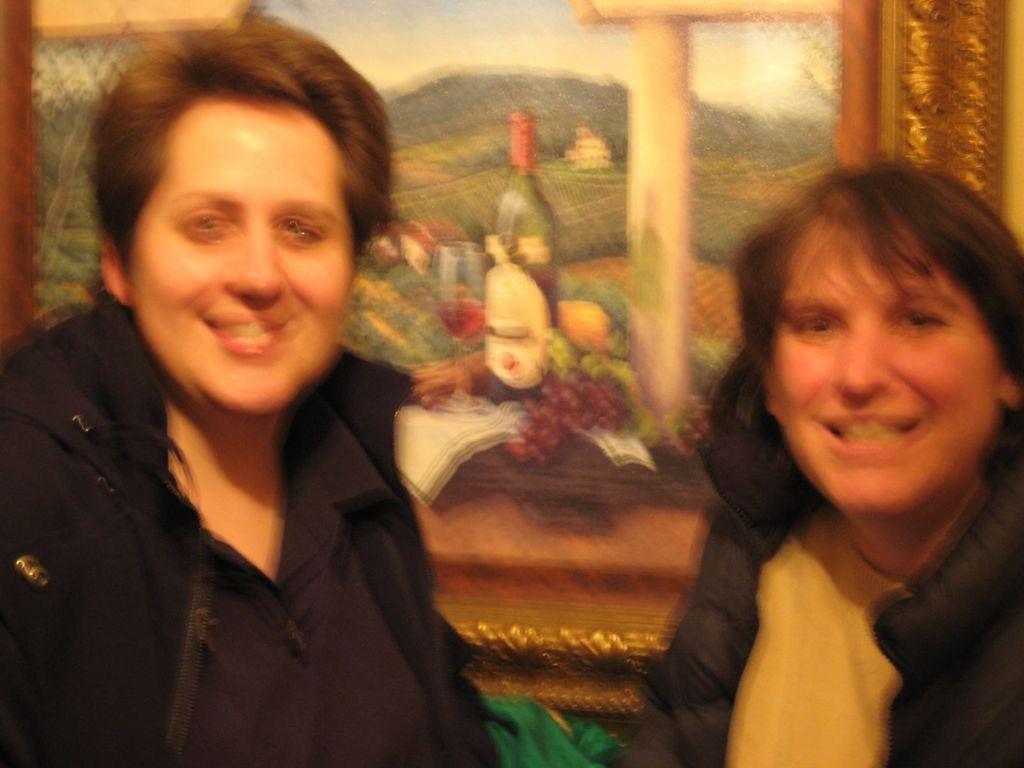Could you give a brief overview of what you see in this image? In this picture we can see a blurry image of 2 people looking and smiling at someone. 